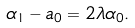Convert formula to latex. <formula><loc_0><loc_0><loc_500><loc_500>\alpha _ { 1 } - a _ { 0 } = 2 \lambda \alpha _ { 0 } .</formula> 